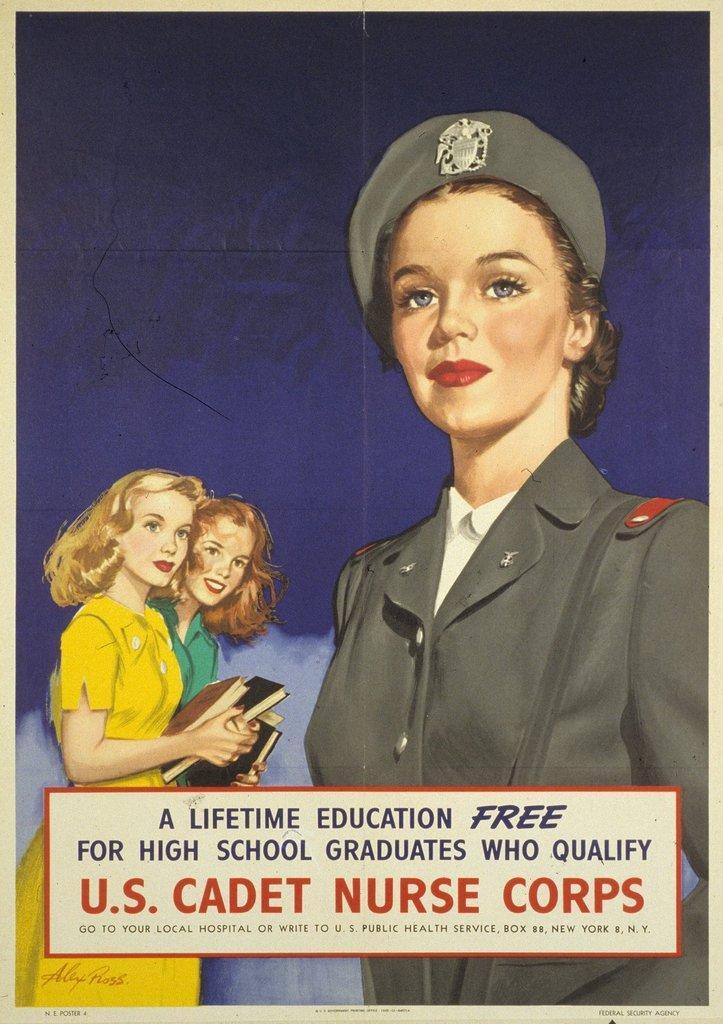In one or two sentences, can you explain what this image depicts? In this image there is a poster with images of three women, at the bottom of the image there is some text and the two women are holding books in their hands. 